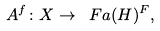<formula> <loc_0><loc_0><loc_500><loc_500>A ^ { f } \colon X \to \ F a ( H ) ^ { F } ,</formula> 